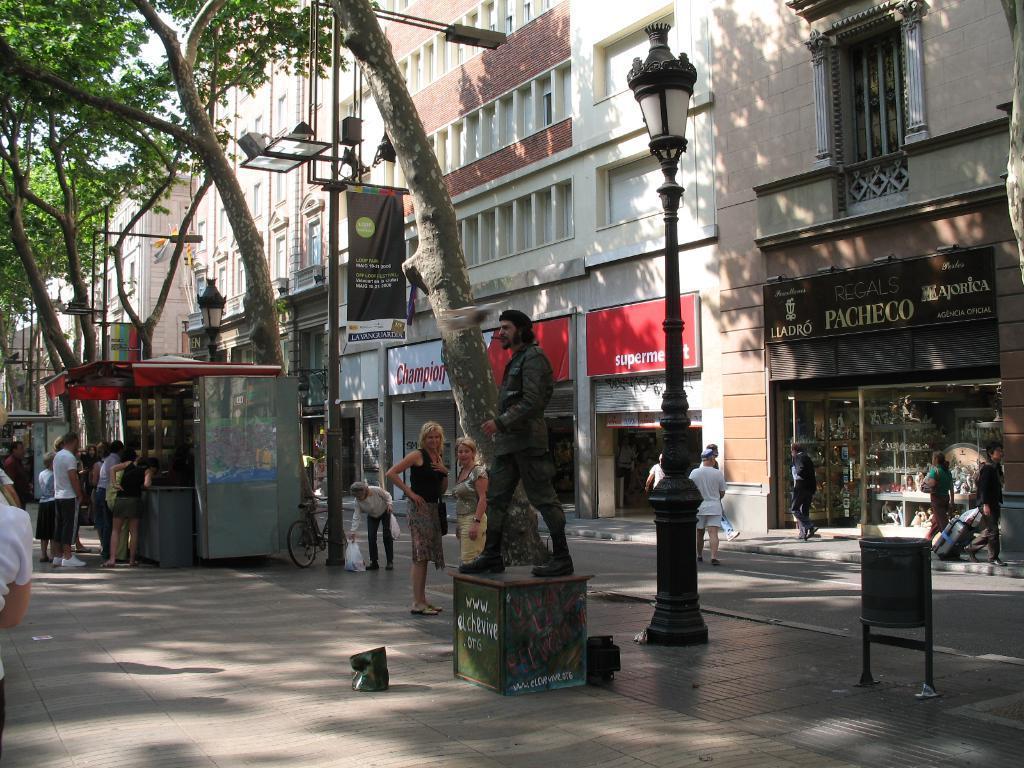Can you describe this image briefly? In this image I can see the ground, a statue of a person, few black colored poles, a bin, a store and few persons standing in front of it, a bicycle and few trees. I can see few buildings, few boards, few persons standing on the sidewalk and the sky in the background. 